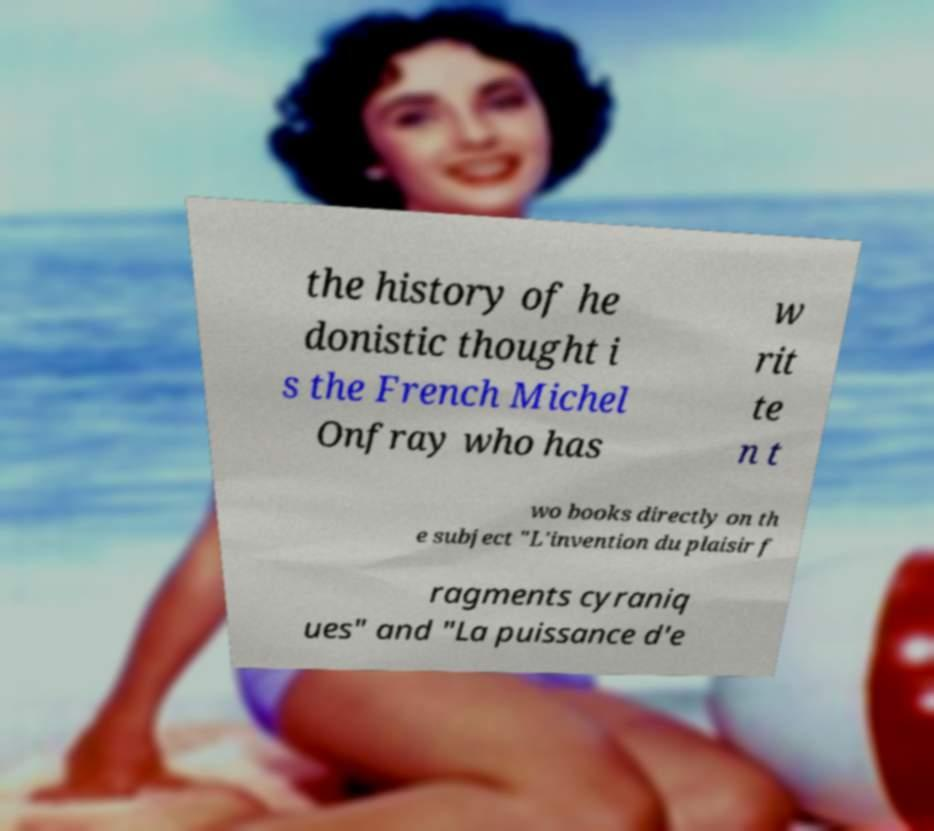For documentation purposes, I need the text within this image transcribed. Could you provide that? the history of he donistic thought i s the French Michel Onfray who has w rit te n t wo books directly on th e subject "L'invention du plaisir f ragments cyraniq ues" and "La puissance d'e 